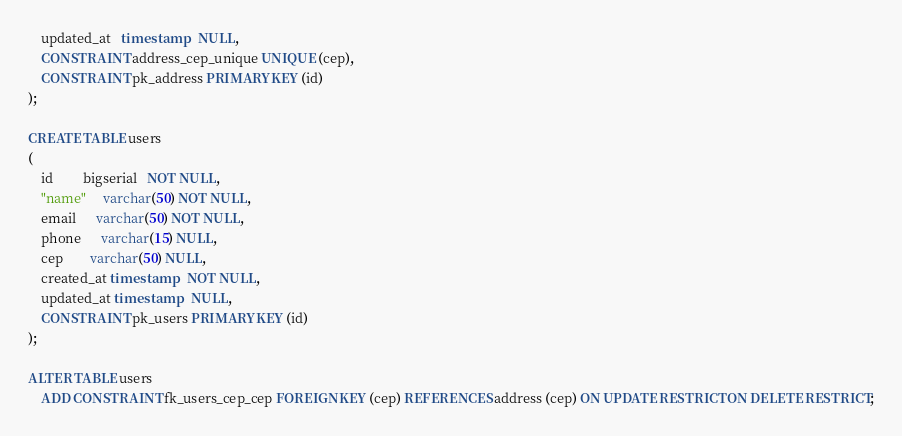<code> <loc_0><loc_0><loc_500><loc_500><_SQL_>    updated_at   timestamp   NULL,
    CONSTRAINT address_cep_unique UNIQUE (cep),
    CONSTRAINT pk_address PRIMARY KEY (id)
);

CREATE TABLE users
(
    id         bigserial   NOT NULL,
    "name"     varchar(50) NOT NULL,
    email      varchar(50) NOT NULL,
    phone      varchar(15) NULL,
    cep        varchar(50) NULL,
    created_at timestamp   NOT NULL,
    updated_at timestamp   NULL,
    CONSTRAINT pk_users PRIMARY KEY (id)
);

ALTER TABLE users
    ADD CONSTRAINT fk_users_cep_cep FOREIGN KEY (cep) REFERENCES address (cep) ON UPDATE RESTRICT ON DELETE RESTRICT;
</code> 